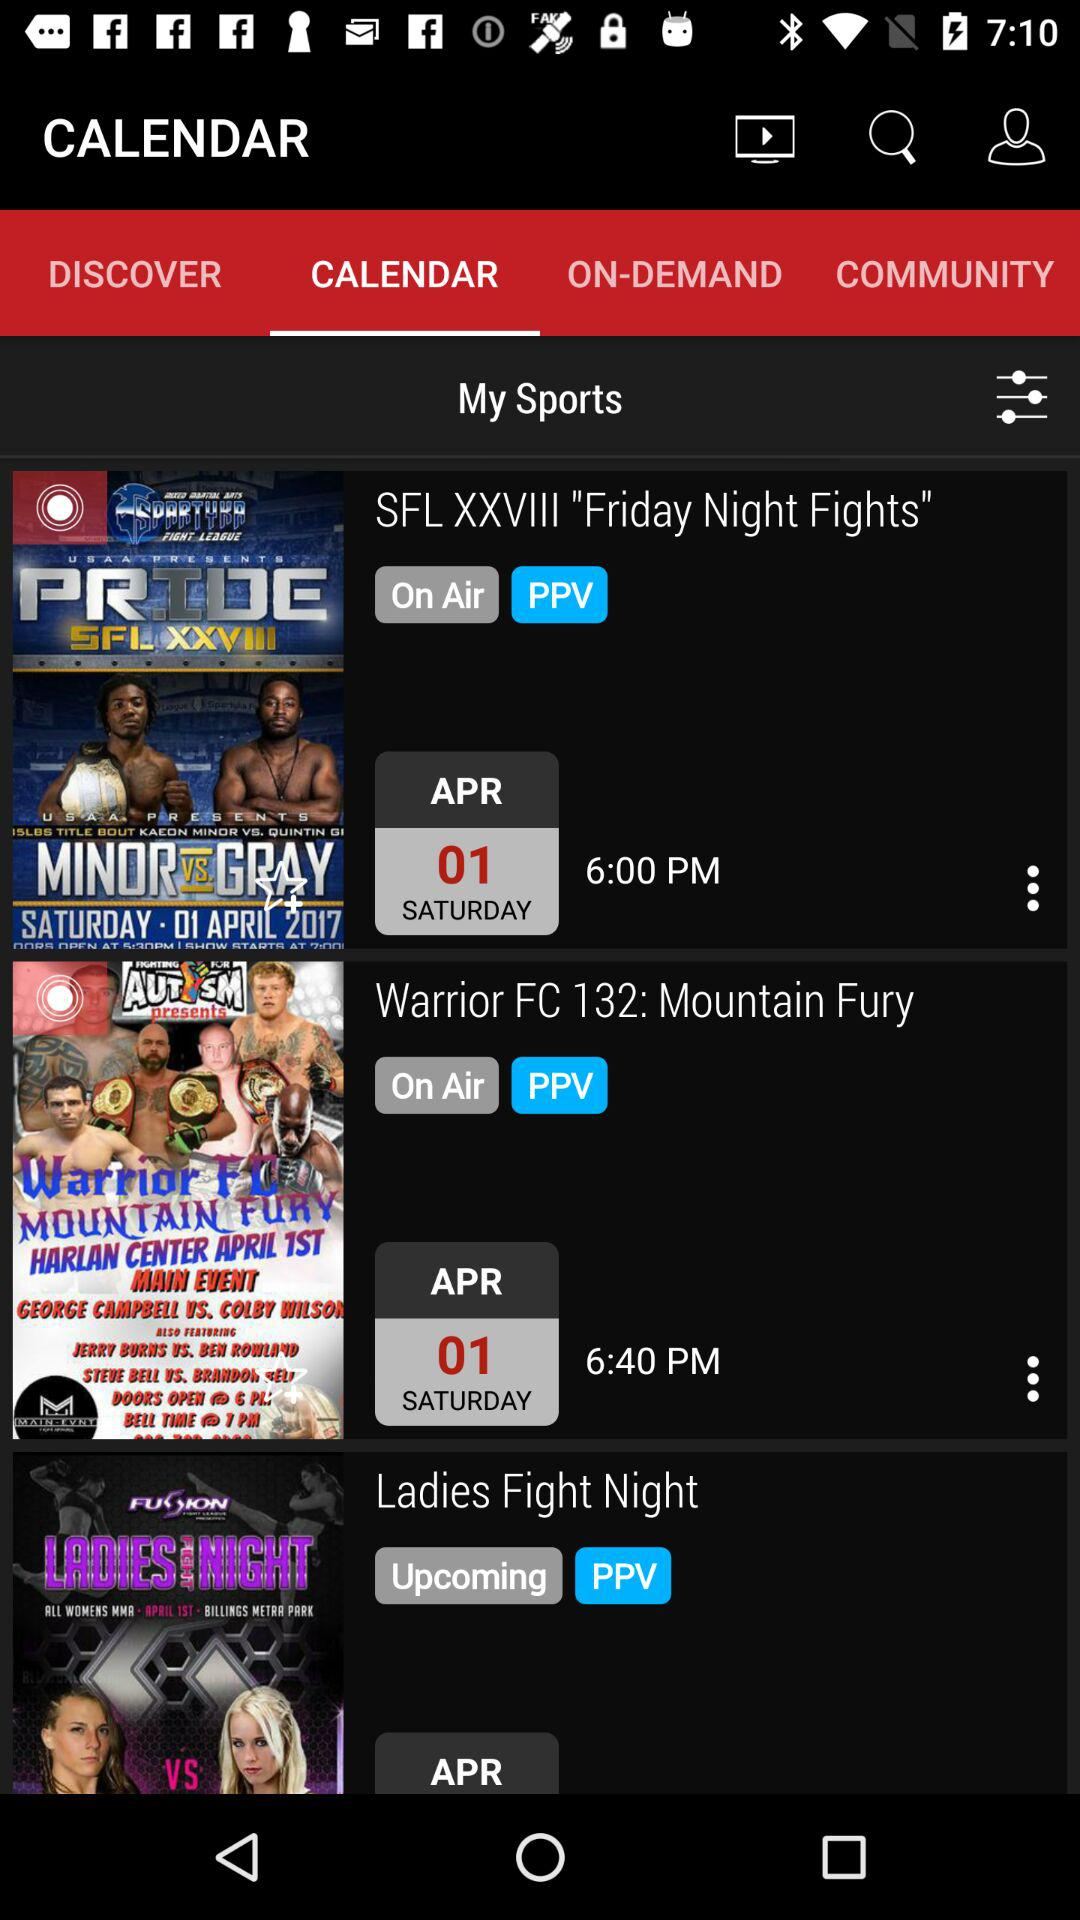Which tab is selected? The selected tab is "CALENDAR". 